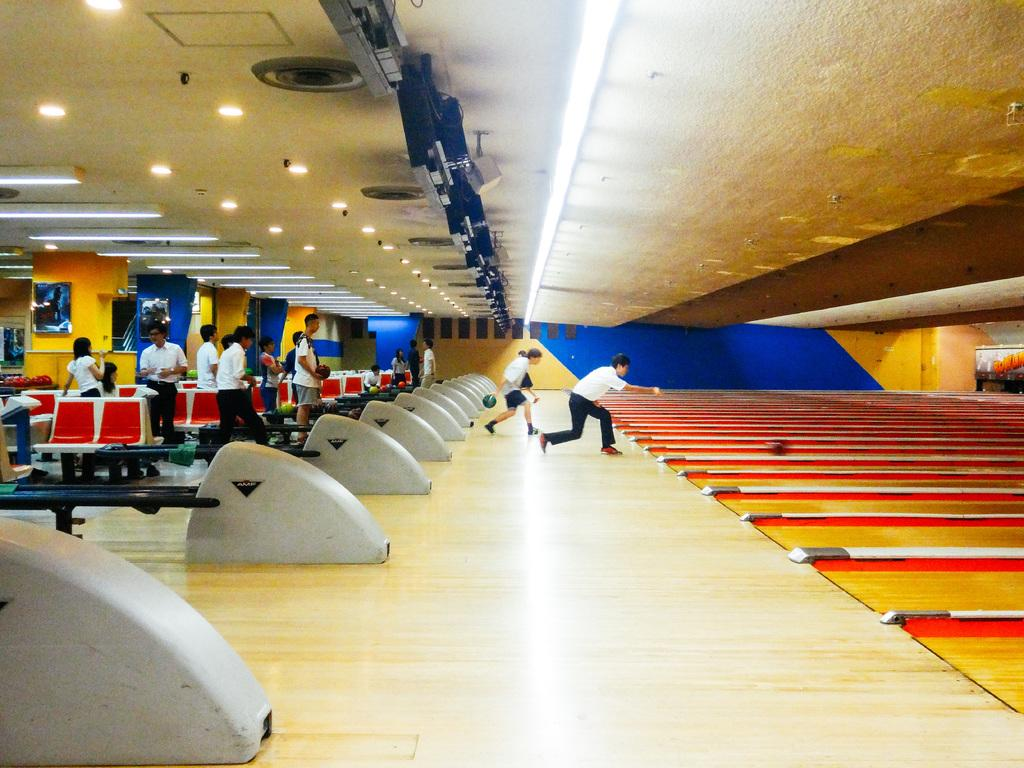Who or what is present in the image? There are people in the image. What type of floor is visible in the image? There is a bowling floor in the image. What objects are used for playing the game in the image? Balls are visible in the image. What type of furniture is present in the image? Chairs are visible in the image. What architectural features can be seen in the image? Boards on pillars are present in the image. What is visible at the top of the image? Lights and boards are visible at the top of the image. What type of quiver can be seen on the bowling floor in the image? There is no quiver present in the image; it is a bowling alley with balls and chairs. Can you see any bubbles floating around the people in the image? There are no bubbles visible in the image; it is a bowling alley with people, balls, chairs, and other features. 